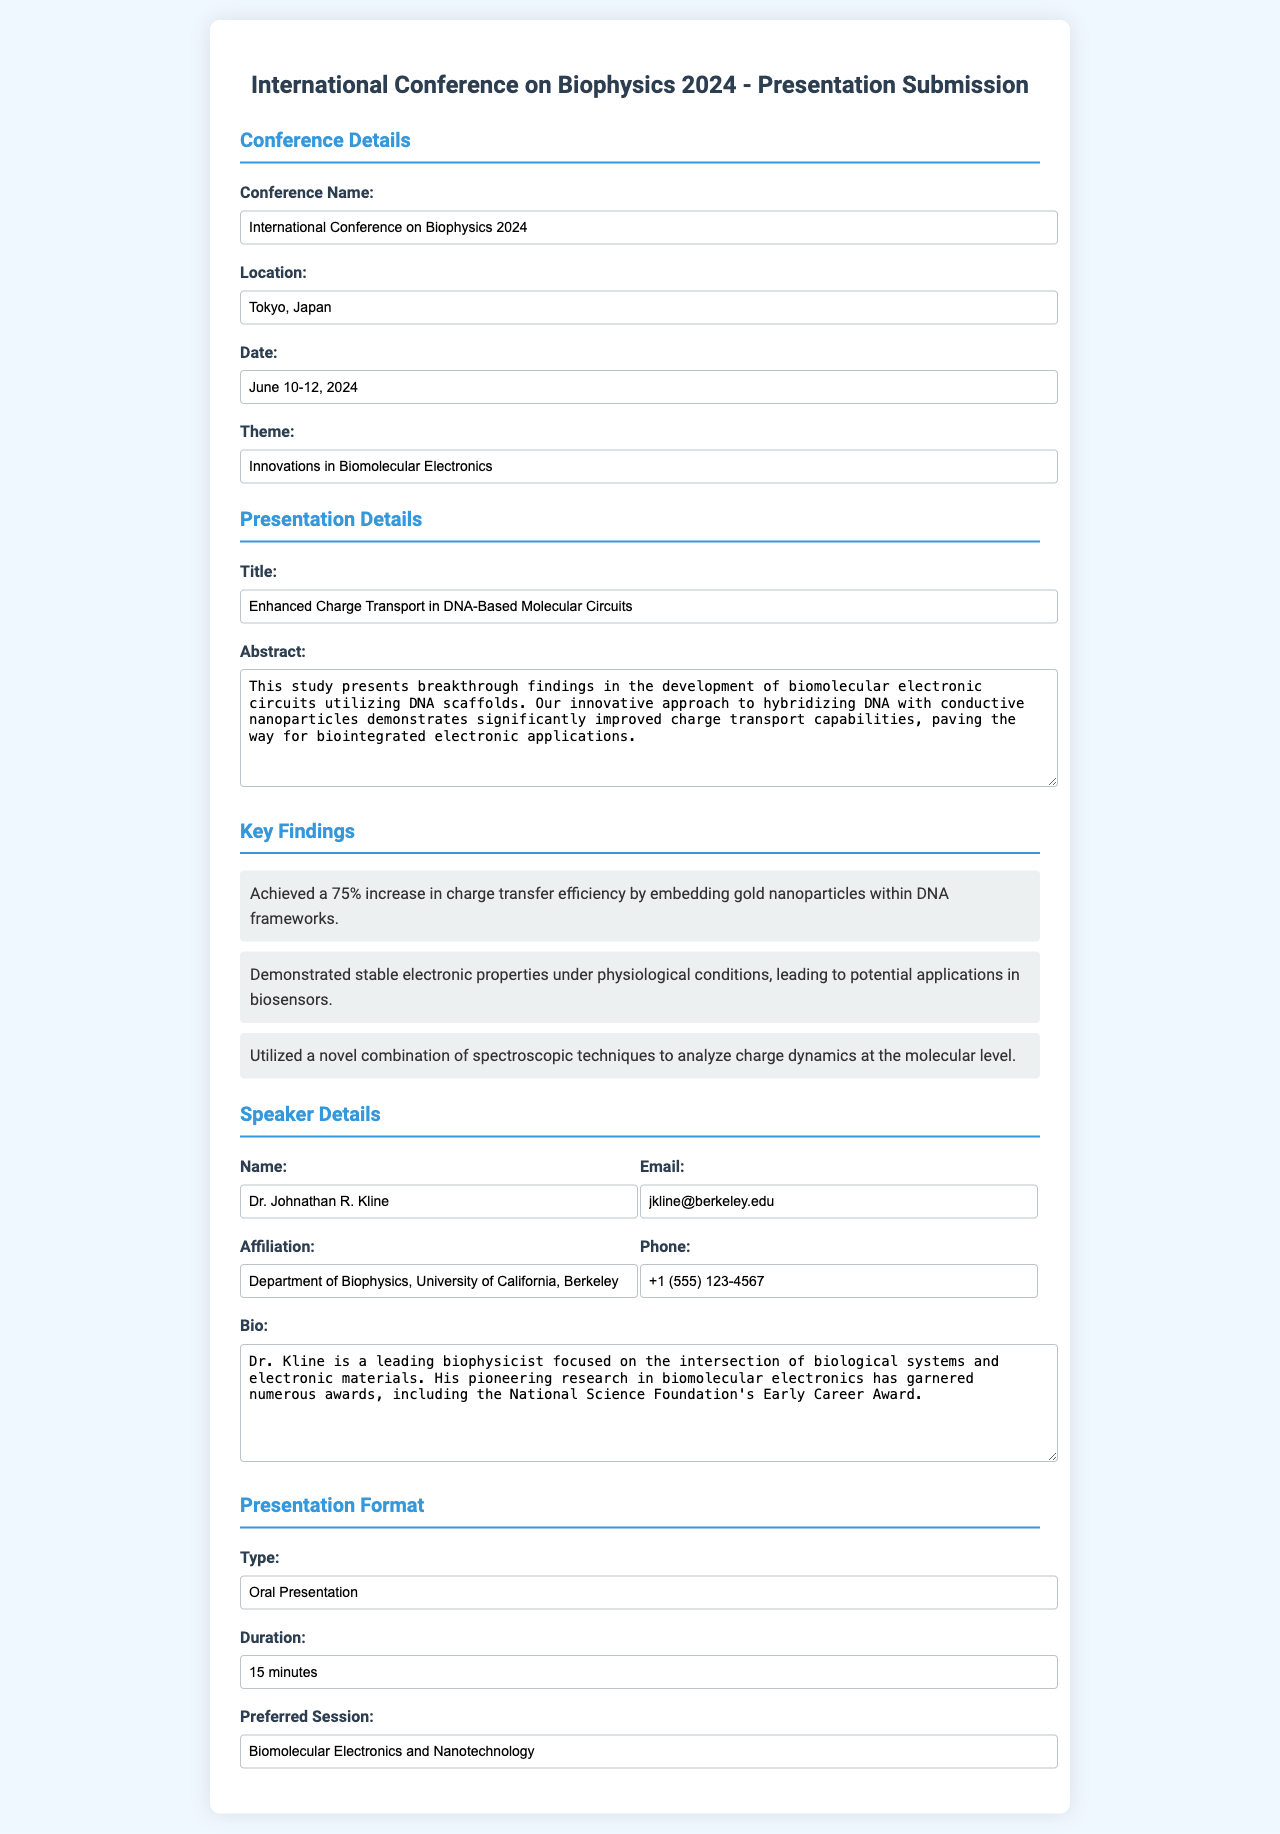what is the conference name? The conference name is mentioned in the details section of the document.
Answer: International Conference on Biophysics 2024 where is the conference located? The location of the conference is specified in the document.
Answer: Tokyo, Japan what are the dates of the conference? The dates can be found in the conference details section.
Answer: June 10-12, 2024 what is the title of the presentation? The title is given under the presentation details section.
Answer: Enhanced Charge Transport in DNA-Based Molecular Circuits who is the speaker? The name of the speaker is listed in the speaker details section.
Answer: Dr. Johnathan R. Kline what is the email of the speaker? The speaker's email is provided in the contact information of the speaker details.
Answer: jkline@berkeley.edu how long is the presentation duration? The duration is stated in the presentation format section of the document.
Answer: 15 minutes what is the preferred session for the presentation? The preferred session is specified in the presentation format section.
Answer: Biomolecular Electronics and Nanotechnology what was a key finding of the study? Key findings are listed under the key findings section of the document.
Answer: Achieved a 75% increase in charge transfer efficiency by embedding gold nanoparticles within DNA frameworks what type of presentation is being submitted? The type of presentation is indicated in the presentation format section.
Answer: Oral Presentation 